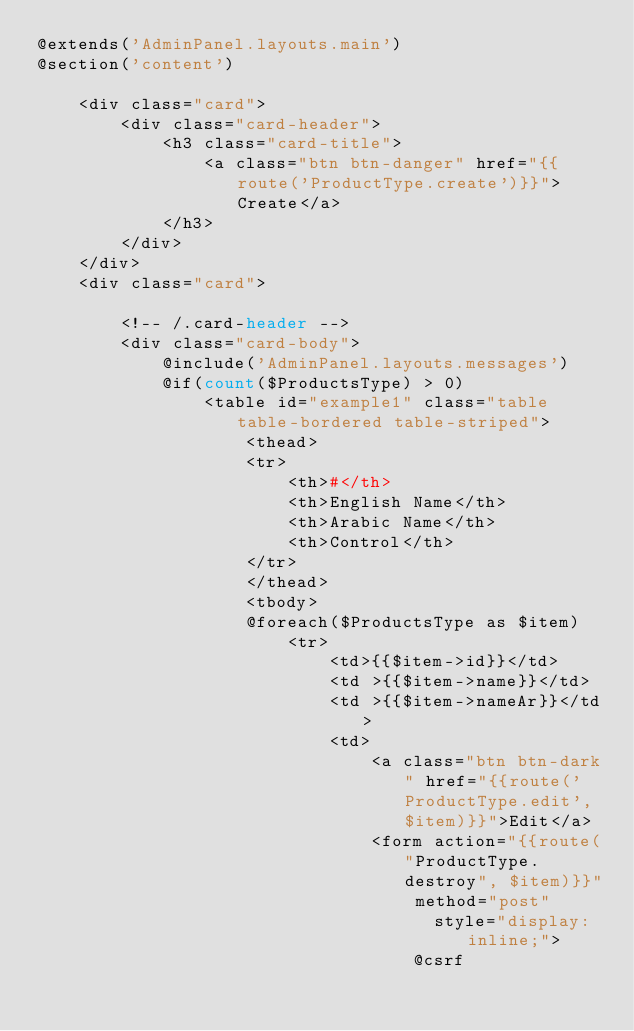Convert code to text. <code><loc_0><loc_0><loc_500><loc_500><_PHP_>@extends('AdminPanel.layouts.main')
@section('content')

    <div class="card">
        <div class="card-header">
            <h3 class="card-title">
                <a class="btn btn-danger" href="{{route('ProductType.create')}}">Create</a>
            </h3>
        </div>
    </div>
    <div class="card">

        <!-- /.card-header -->
        <div class="card-body">
            @include('AdminPanel.layouts.messages')
            @if(count($ProductsType) > 0)
                <table id="example1" class="table table-bordered table-striped">
                    <thead>
                    <tr>
                        <th>#</th>
                        <th>English Name</th>
                        <th>Arabic Name</th>
                        <th>Control</th>
                    </tr>
                    </thead>
                    <tbody>
                    @foreach($ProductsType as $item)
                        <tr>
                            <td>{{$item->id}}</td>
                            <td >{{$item->name}}</td>
                            <td >{{$item->nameAr}}</td>
                            <td>
                                <a class="btn btn-dark" href="{{route('ProductType.edit',$item)}}">Edit</a>
                                <form action="{{route("ProductType.destroy", $item)}}" method="post"
                                      style="display:inline;">
                                    @csrf</code> 